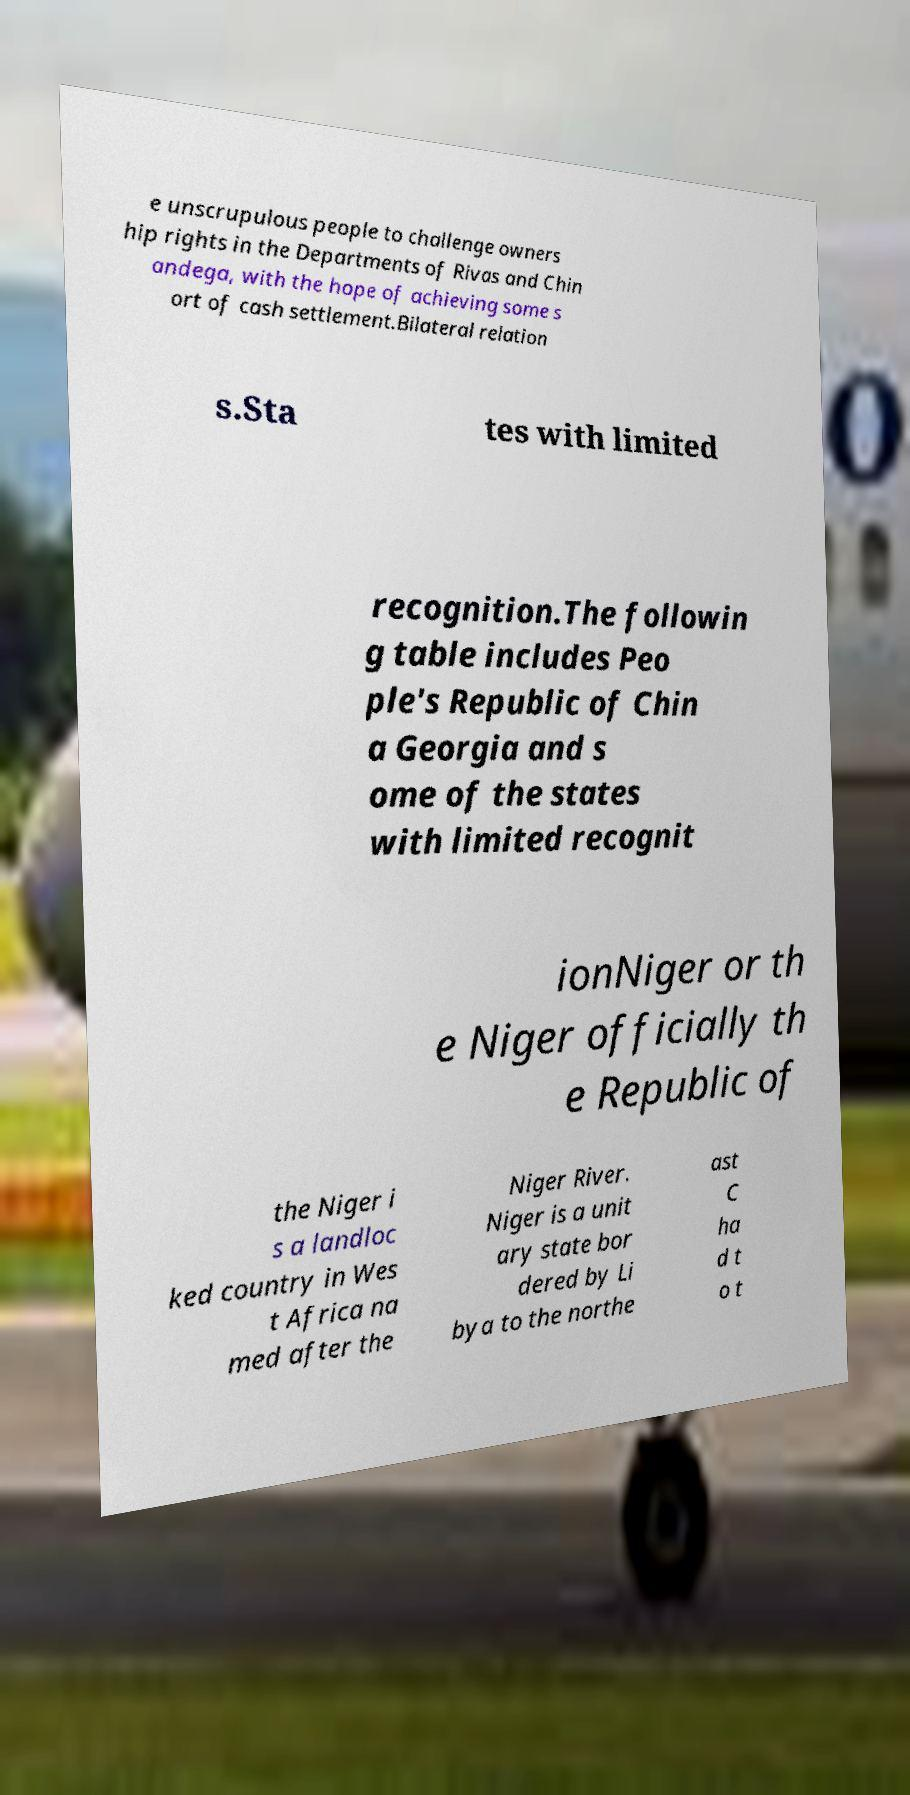Could you assist in decoding the text presented in this image and type it out clearly? e unscrupulous people to challenge owners hip rights in the Departments of Rivas and Chin andega, with the hope of achieving some s ort of cash settlement.Bilateral relation s.Sta tes with limited recognition.The followin g table includes Peo ple's Republic of Chin a Georgia and s ome of the states with limited recognit ionNiger or th e Niger officially th e Republic of the Niger i s a landloc ked country in Wes t Africa na med after the Niger River. Niger is a unit ary state bor dered by Li bya to the northe ast C ha d t o t 